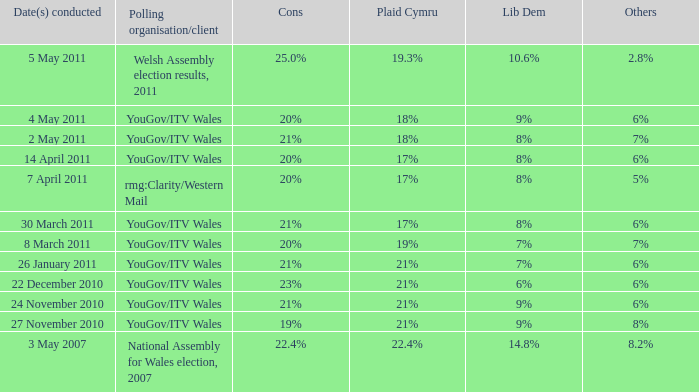I want the plaid cymru for Polling organisation/client of yougov/itv wales for 4 may 2011 18%. 